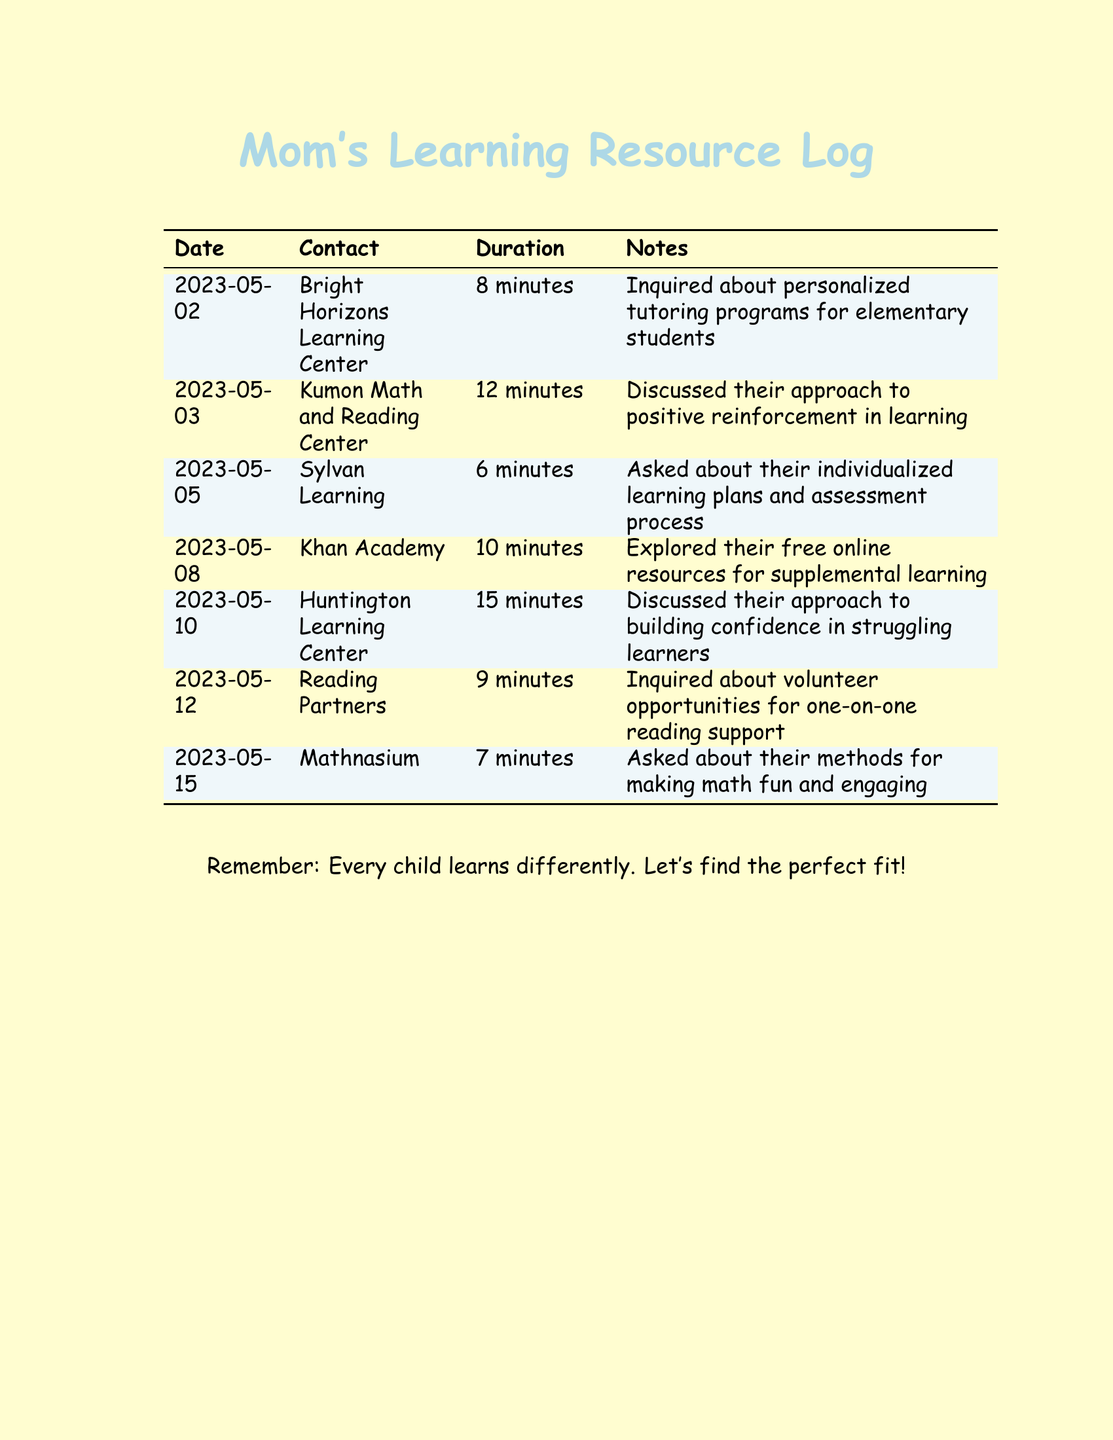What is the date of the first call? The first call was made to Bright Horizons Learning Center on May 2, 2023.
Answer: May 2, 2023 How long was the call to Kumon Math and Reading Center? The duration of the call to Kumon Math and Reading Center was 12 minutes.
Answer: 12 minutes What topic was discussed during the call with Huntington Learning Center? During the call with Huntington Learning Center, the discussion was focused on building confidence in struggling learners.
Answer: Building confidence in struggling learners Which tutoring service was contacted on May 5, 2023? The tutoring service contacted on May 5, 2023, was Sylvan Learning.
Answer: Sylvan Learning What is a resource mentioned in the call with Khan Academy? The call with Khan Academy explored their free online resources for supplemental learning.
Answer: Free online resources How many minutes were spent discussing individualized learning plans with Sylvan Learning? The call to Sylvan Learning regarding individualized learning plans lasted 6 minutes.
Answer: 6 minutes What type of opportunities did the call to Reading Partners inquire about? The call to Reading Partners inquired about volunteer opportunities for one-on-one reading support.
Answer: Volunteer opportunities for one-on-one reading support Which center's approach to positive reinforcement in learning was discussed? The approach to positive reinforcement in learning discussed was from Kumon Math and Reading Center.
Answer: Kumon Math and Reading Center 